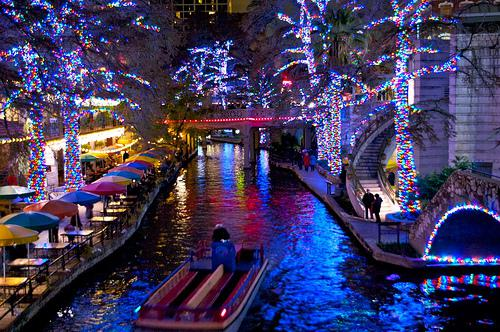Question: who is in the picture?
Choices:
A. Kids.
B. Tourists.
C. Women.
D. Policemen.
Answer with the letter. Answer: B Question: where was this taken?
Choices:
A. Beach.
B. Mountains.
C. Backyard.
D. River.
Answer with the letter. Answer: D Question: why are the trees lit?
Choices:
A. Celebration.
B. Christmas.
C. For illumination.
D. Candles.
Answer with the letter. Answer: A Question: when was this taken?
Choices:
A. Morning.
B. Night.
C. Dusk.
D. Day.
Answer with the letter. Answer: B 